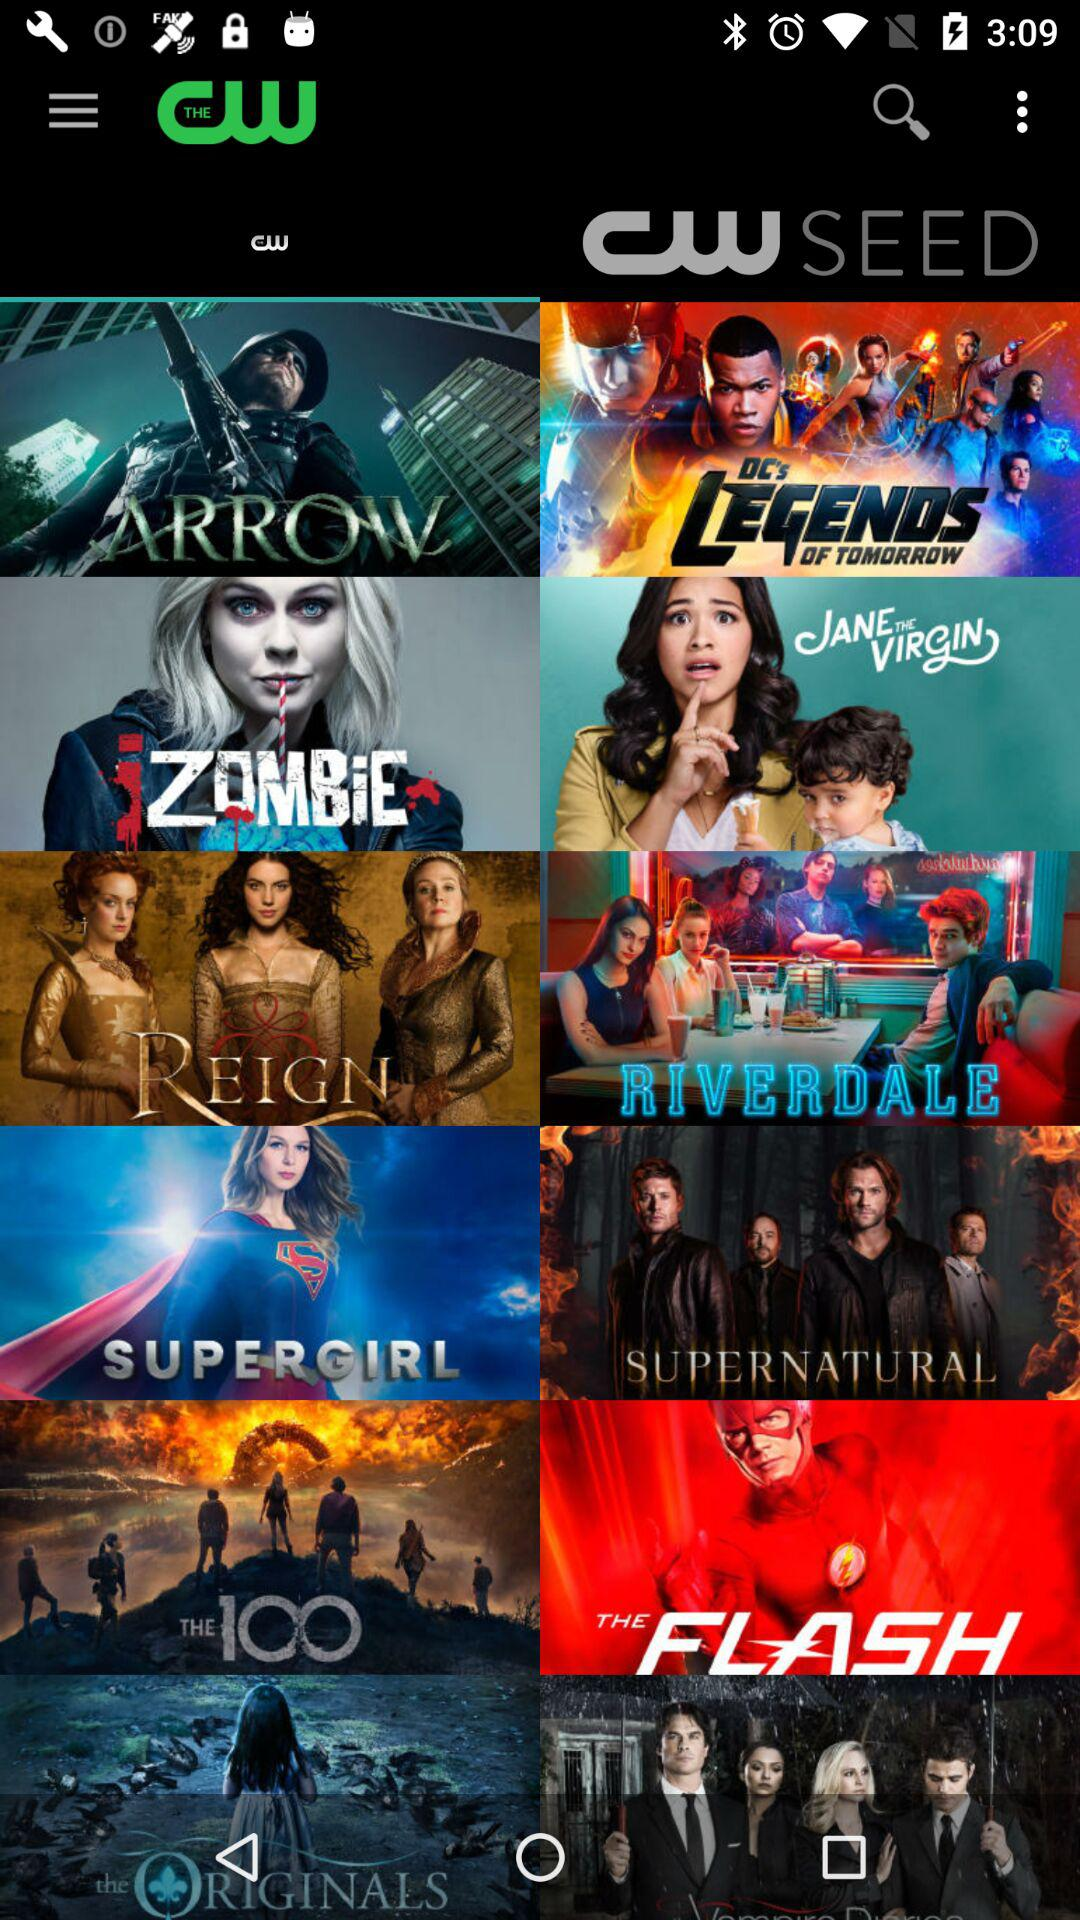What is the application name? The application name is "THE CW". 